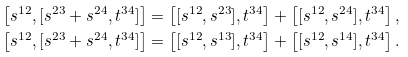Convert formula to latex. <formula><loc_0><loc_0><loc_500><loc_500>\left [ s ^ { 1 2 } , [ s ^ { 2 3 } + s ^ { 2 4 } , t ^ { 3 4 } ] \right ] & = \left [ [ s ^ { 1 2 } , s ^ { 2 3 } ] , t ^ { 3 4 } \right ] + \left [ [ s ^ { 1 2 } , s ^ { 2 4 } ] , t ^ { 3 4 } \right ] , \\ \left [ s ^ { 1 2 } , [ s ^ { 2 3 } + s ^ { 2 4 } , t ^ { 3 4 } ] \right ] & = \left [ [ s ^ { 1 2 } , s ^ { 1 3 } ] , t ^ { 3 4 } \right ] + \left [ [ s ^ { 1 2 } , s ^ { 1 4 } ] , t ^ { 3 4 } \right ] .</formula> 